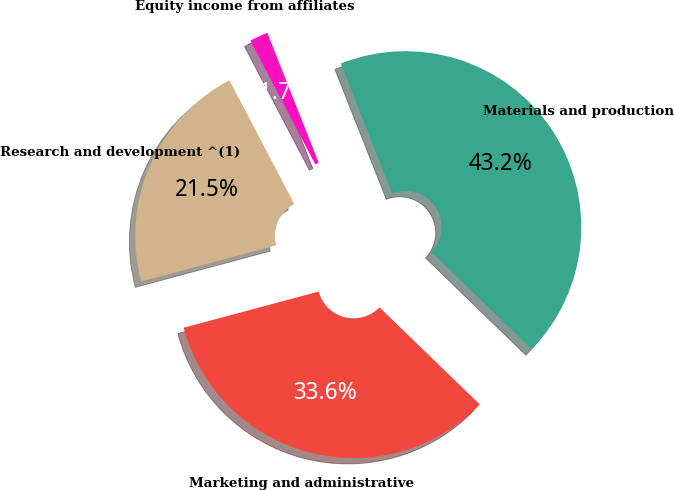Convert chart to OTSL. <chart><loc_0><loc_0><loc_500><loc_500><pie_chart><fcel>Materials and production<fcel>Marketing and administrative<fcel>Research and development ^(1)<fcel>Equity income from affiliates<nl><fcel>43.24%<fcel>33.59%<fcel>21.48%<fcel>1.69%<nl></chart> 